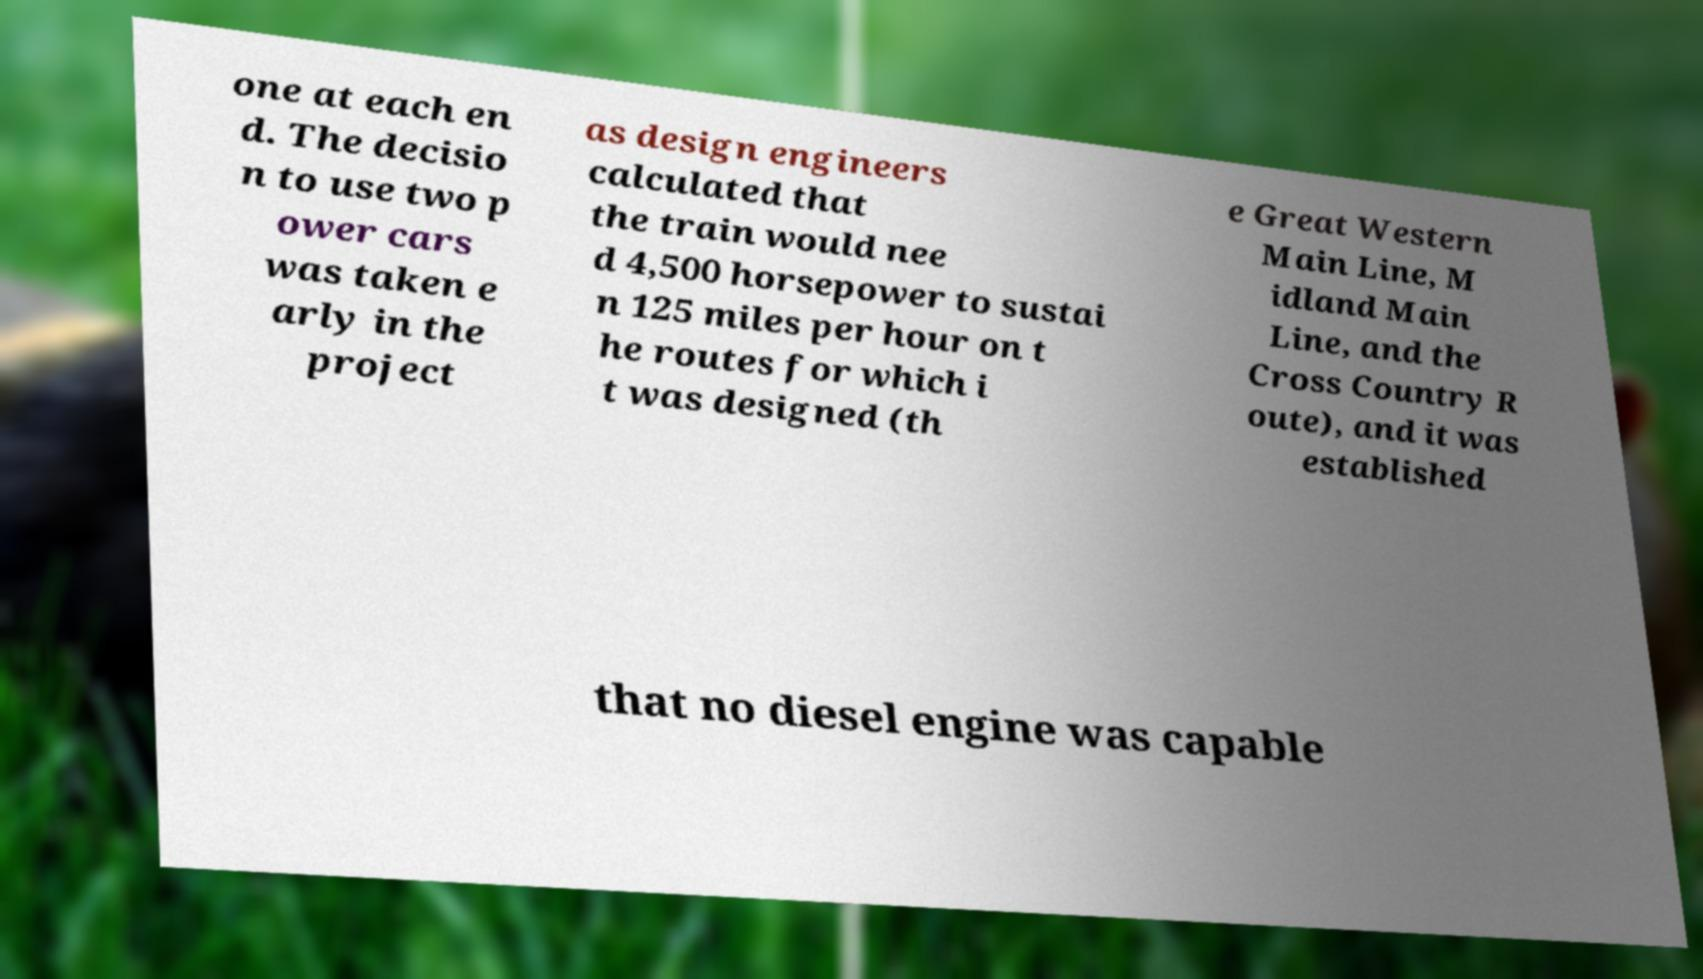For documentation purposes, I need the text within this image transcribed. Could you provide that? one at each en d. The decisio n to use two p ower cars was taken e arly in the project as design engineers calculated that the train would nee d 4,500 horsepower to sustai n 125 miles per hour on t he routes for which i t was designed (th e Great Western Main Line, M idland Main Line, and the Cross Country R oute), and it was established that no diesel engine was capable 